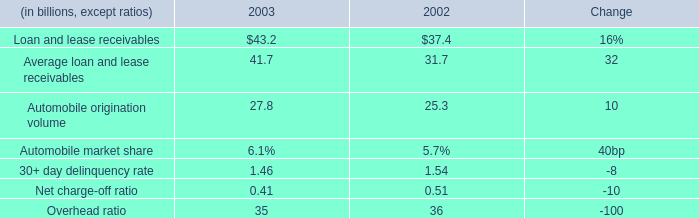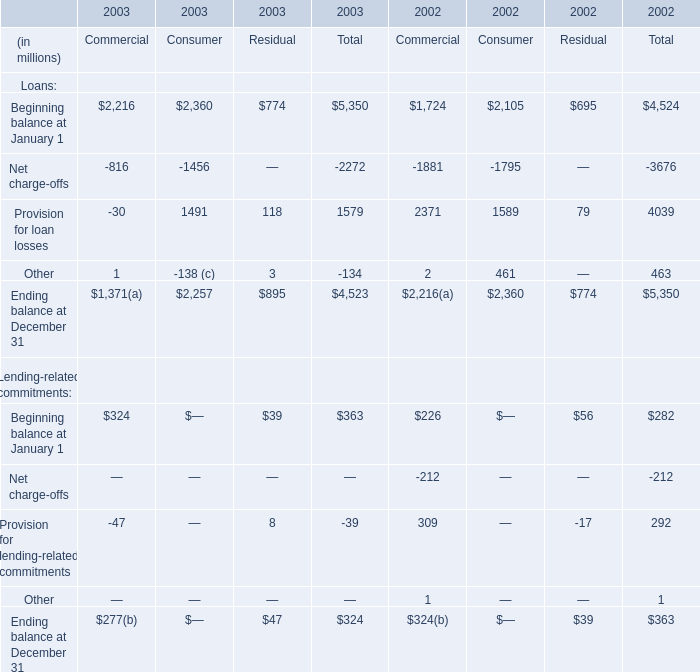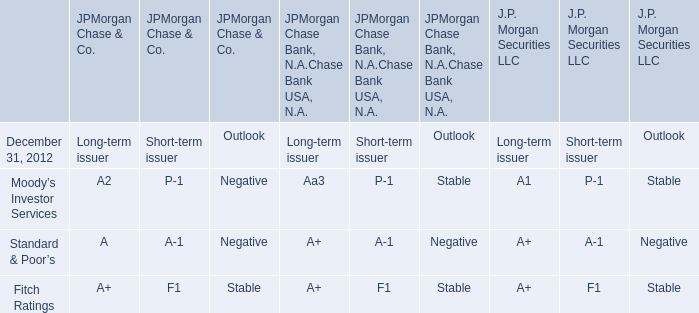Which year is Beginning balance the most for Total? 
Answer: 2003. 